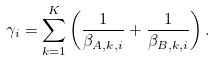Convert formula to latex. <formula><loc_0><loc_0><loc_500><loc_500>\gamma _ { i } = \sum _ { k = 1 } ^ { K } \left ( \frac { 1 } { \beta _ { A , k , i } } + \frac { 1 } { \beta _ { B , k , i } } \right ) .</formula> 